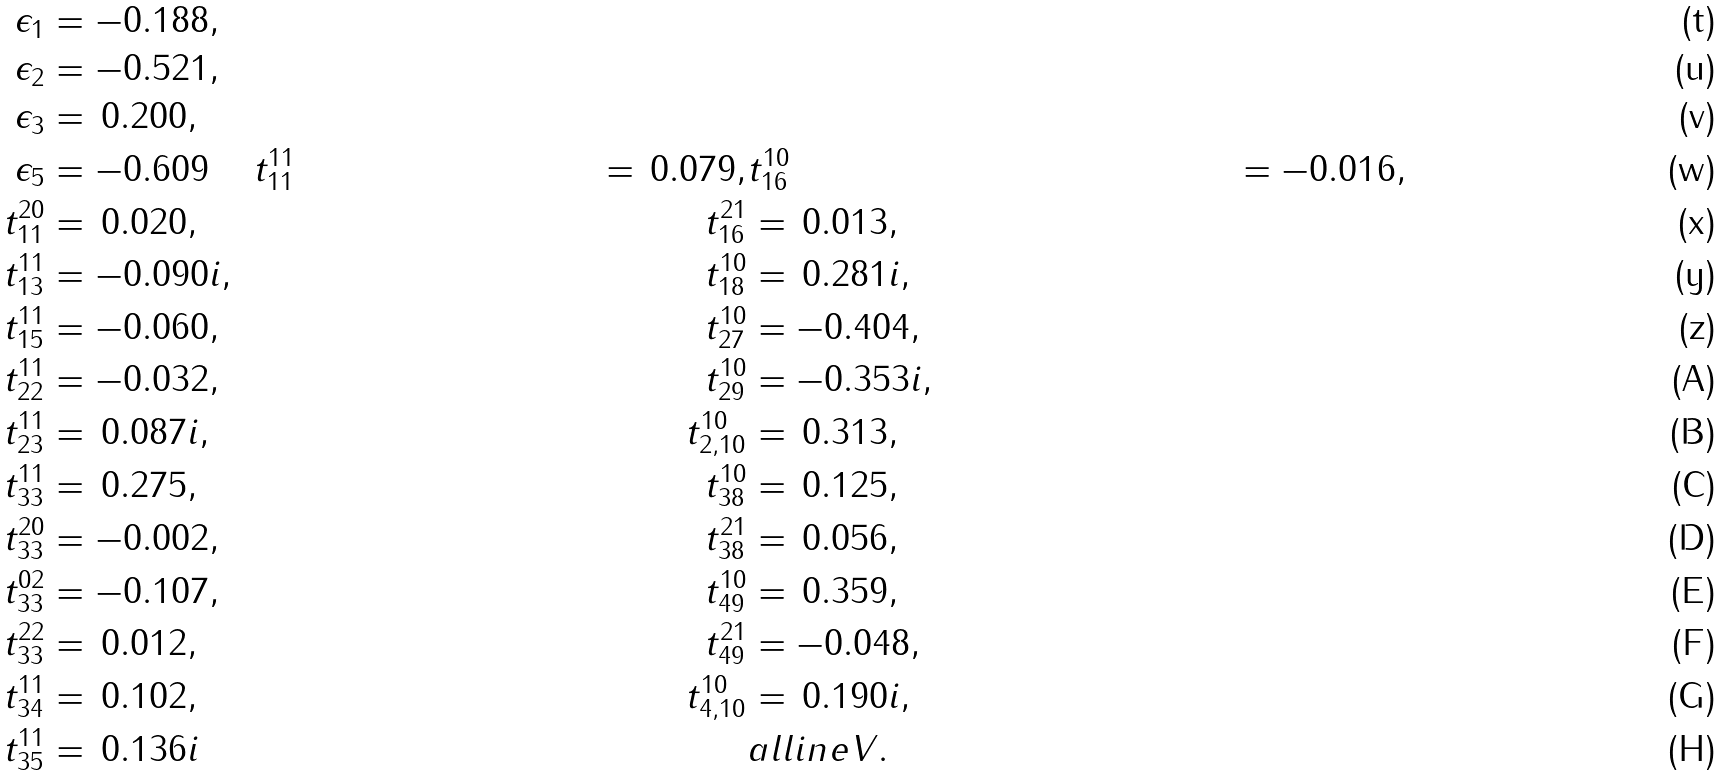Convert formula to latex. <formula><loc_0><loc_0><loc_500><loc_500>\epsilon _ { 1 } & = - 0 . 1 8 8 , \\ \epsilon _ { 2 } & = - 0 . 5 2 1 , \\ \epsilon _ { 3 } & = \, 0 . 2 0 0 , \\ \epsilon _ { 5 } & = - 0 . 6 0 9 \quad \, t ^ { 1 1 } _ { 1 1 } & = \, 0 . 0 7 9 , & t ^ { 1 0 } _ { 1 6 } & = - 0 . 0 1 6 , \\ t ^ { 2 0 } _ { 1 1 } & = \, 0 . 0 2 0 , & t ^ { 2 1 } _ { 1 6 } & = \, 0 . 0 1 3 , \\ t ^ { 1 1 } _ { 1 3 } & = - 0 . 0 9 0 i , & t ^ { 1 0 } _ { 1 8 } & = \, 0 . 2 8 1 i , \\ t ^ { 1 1 } _ { 1 5 } & = - 0 . 0 6 0 , & t ^ { 1 0 } _ { 2 7 } & = - 0 . 4 0 4 , \\ t ^ { 1 1 } _ { 2 2 } & = - 0 . 0 3 2 , & t ^ { 1 0 } _ { 2 9 } & = - 0 . 3 5 3 i , \\ t ^ { 1 1 } _ { 2 3 } & = \, 0 . 0 8 7 i , & t ^ { 1 0 } _ { 2 , 1 0 } & = \, 0 . 3 1 3 , \\ t ^ { 1 1 } _ { 3 3 } & = \, 0 . 2 7 5 , & t ^ { 1 0 } _ { 3 8 } & = \, 0 . 1 2 5 , \\ t ^ { 2 0 } _ { 3 3 } & = - 0 . 0 0 2 , & t ^ { 2 1 } _ { 3 8 } & = \, 0 . 0 5 6 , \\ t ^ { 0 2 } _ { 3 3 } & = - 0 . 1 0 7 , & t ^ { 1 0 } _ { 4 9 } & = \, 0 . 3 5 9 , \\ t ^ { 2 2 } _ { 3 3 } & = \, 0 . 0 1 2 , & t ^ { 2 1 } _ { 4 9 } & = - 0 . 0 4 8 , \\ t ^ { 1 1 } _ { 3 4 } & = \, 0 . 1 0 2 , & t ^ { 1 0 } _ { 4 , 1 0 } & = \, 0 . 1 9 0 i , \\ t ^ { 1 1 } _ { 3 5 } & = \, 0 . 1 3 6 i & & a l l i n e V .</formula> 